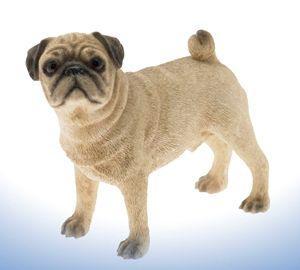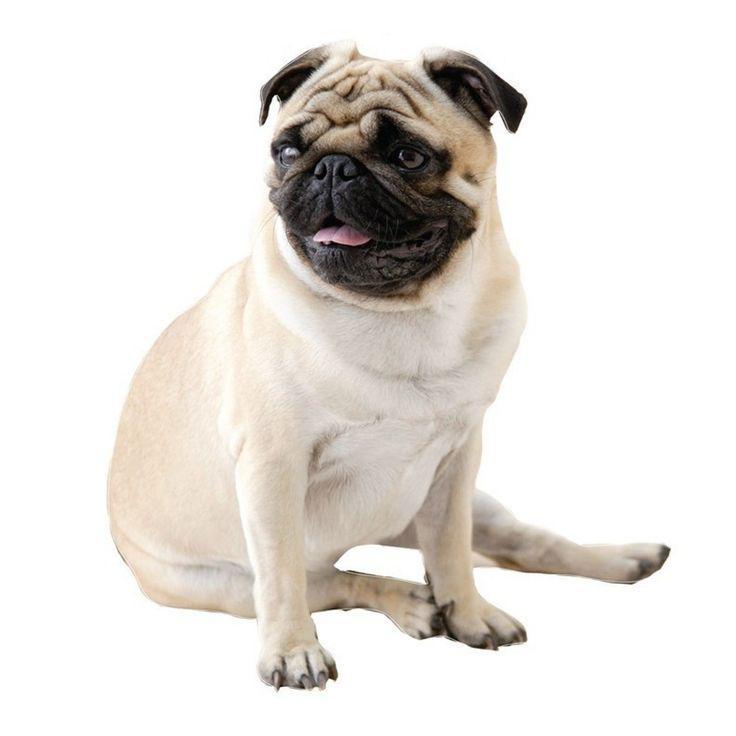The first image is the image on the left, the second image is the image on the right. Examine the images to the left and right. Is the description "In one of the images, a dog is sitting down" accurate? Answer yes or no. Yes. 